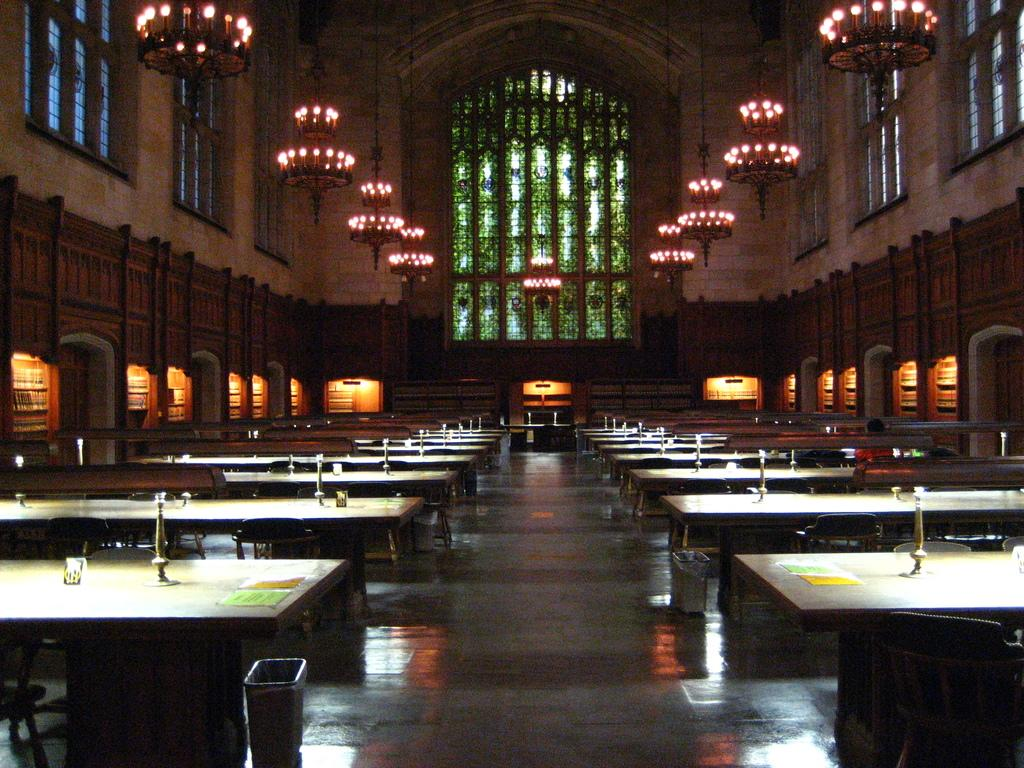What is located in the center of the image? There are tables, vouchers, and dustbins in the center of the image. What other objects can be seen in the center of the image? There are other objects in the center of the image, but their specific details are not mentioned in the provided facts. What can be seen in the background of the image? There is a wall, windows, and lights in the background of the image. Can you see any fish swimming in the image? There is no mention of fish in the image, so we cannot say if any are present. Is there a rose on the table in the image? The provided facts do not mention a rose, so we cannot say if one is present. 